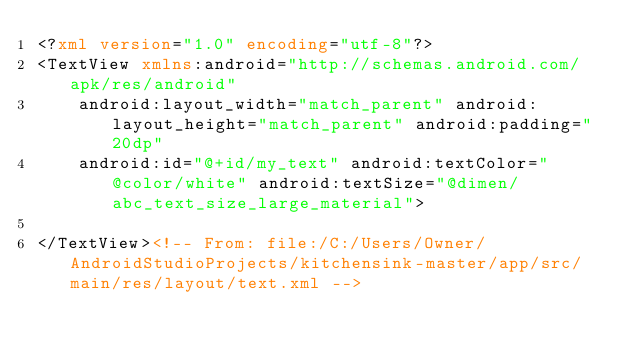<code> <loc_0><loc_0><loc_500><loc_500><_XML_><?xml version="1.0" encoding="utf-8"?>
<TextView xmlns:android="http://schemas.android.com/apk/res/android"
    android:layout_width="match_parent" android:layout_height="match_parent" android:padding="20dp"
    android:id="@+id/my_text" android:textColor="@color/white" android:textSize="@dimen/abc_text_size_large_material">

</TextView><!-- From: file:/C:/Users/Owner/AndroidStudioProjects/kitchensink-master/app/src/main/res/layout/text.xml --></code> 